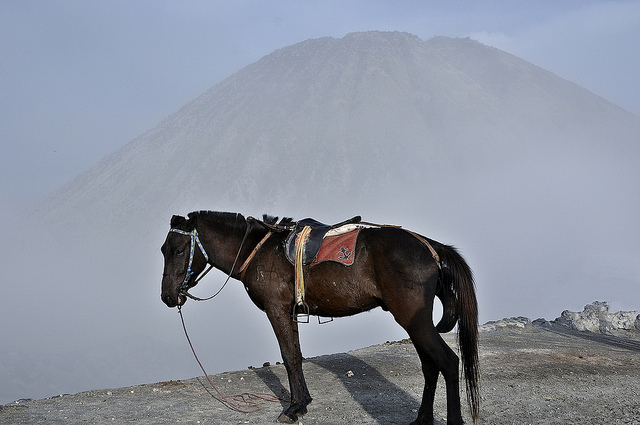What is the function of the saddle and symbols on the horse? The saddle equipped on the horse, along with the visible symbols, indicates that it might be used for practical work or possibly even for tourist rides, especially considering the rugged terrain in the background which suggests a mountainous region. 